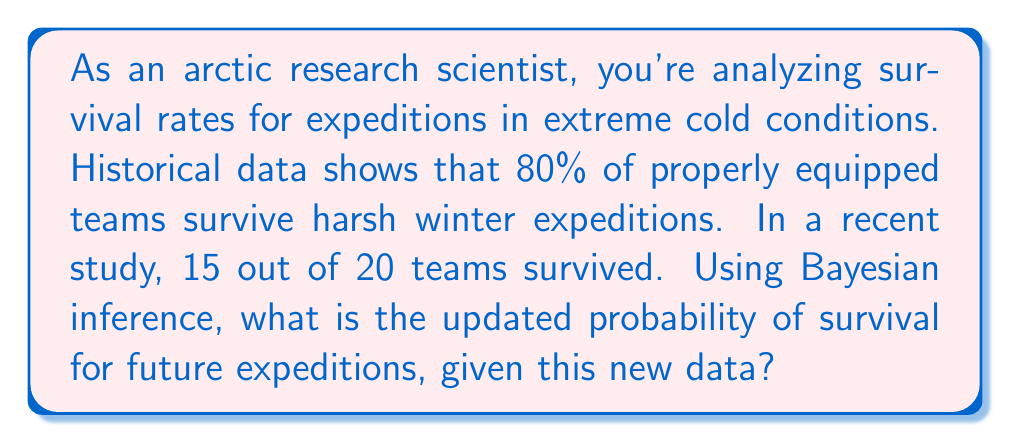Show me your answer to this math problem. Let's approach this step-by-step using Bayesian inference:

1) Define our variables:
   $\theta$ = probability of survival
   $D$ = new data (15 successes out of 20 trials)

2) We need to calculate $P(\theta|D)$ using Bayes' theorem:

   $$P(\theta|D) = \frac{P(D|\theta) \cdot P(\theta)}{P(D)}$$

3) Prior probability $P(\theta)$: Based on historical data, $P(\theta) = 0.8$

4) Likelihood $P(D|\theta)$: This follows a binomial distribution
   
   $$P(D|\theta) = \binom{20}{15} \theta^{15} (1-\theta)^5$$

5) Evidence $P(D)$: This is a normalizing constant, which we can calculate later

6) Combining these in Bayes' theorem:

   $$P(\theta|D) \propto \theta^{15} (1-\theta)^5 \cdot 0.8$$

7) This is proportional to a Beta distribution:

   $$P(\theta|D) \sim \text{Beta}(16, 6)$$

8) The expected value of a Beta(α, β) distribution is $\frac{\alpha}{\alpha + \beta}$

9) Therefore, our updated probability of survival is:

   $$E[\theta|D] = \frac{16}{16 + 6} = \frac{16}{22} \approx 0.7273$$
Answer: 0.7273 